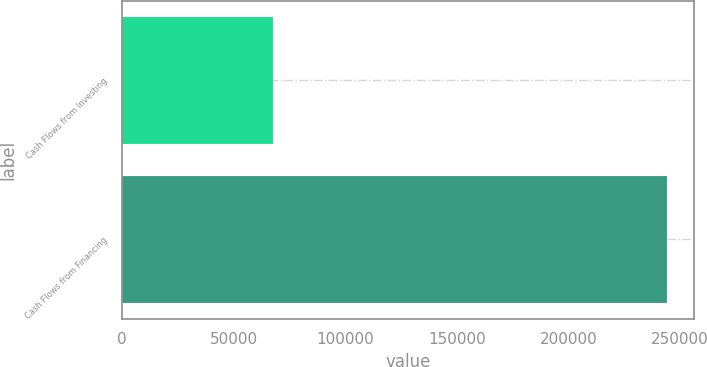Convert chart. <chart><loc_0><loc_0><loc_500><loc_500><bar_chart><fcel>Cash Flows from Investing<fcel>Cash Flows from Financing<nl><fcel>67748<fcel>244185<nl></chart> 